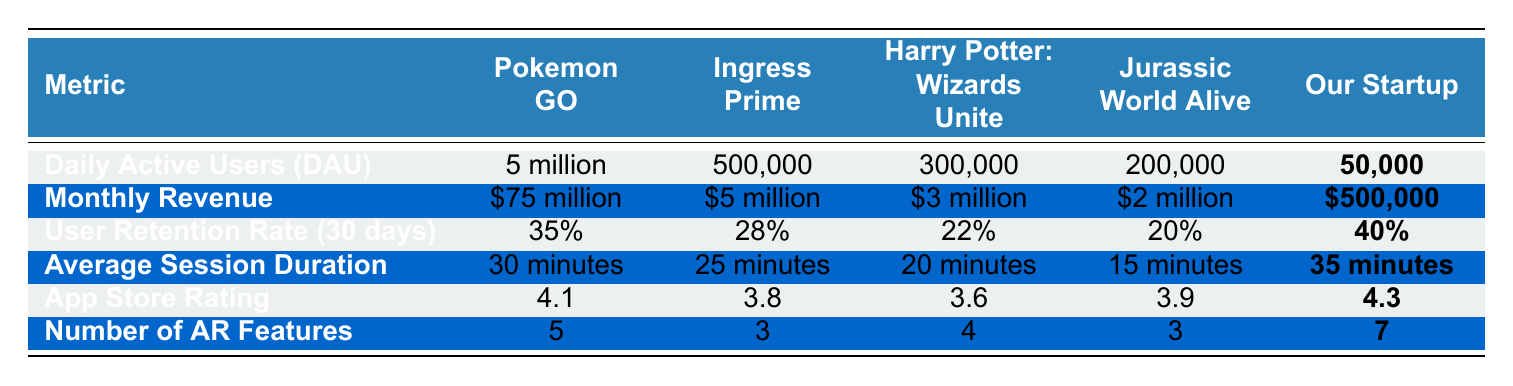What are the Daily Active Users (DAU) of Pokemon GO? The DAU for Pokemon GO is directly listed in the table under the corresponding metric. It is stated as "5 million."
Answer: 5 million Which app has the highest Monthly Revenue? The Monthly Revenue for each app is listed in a separate row. Comparing these values shows that Pokemon GO has the highest with "$75 million."
Answer: $75 million Is our startup's User Retention Rate higher than Ingress Prime's? The User Retention Rate for our startup is given as "40%" and for Ingress Prime as "28%." Since 40% is greater than 28%, the answer is yes.
Answer: Yes What is the average number of AR Features across all five apps? To find the average, sum up the number of AR Features for each app: 5 (Pokemon GO) + 3 (Ingress Prime) + 4 (Harry Potter) + 3 (Jurassic World) + 7 (Our Startup) = 22. Divide by the total number of apps (5) to get an average of 22/5 = 4.4.
Answer: 4.4 Does Harry Potter: Wizards Unite have a higher App Store Rating than Jurassic World Alive? The App Store Ratings are 3.6 for Harry Potter: Wizards Unite and 3.9 for Jurassic World Alive. Since 3.6 is less than 3.9, the answer is no.
Answer: No What is the difference in Average Session Duration between Pokemon GO and Our Startup? The Average Session Duration for Pokemon GO is 30 minutes, and for Our Startup, it is 35 minutes. To find the difference, subtract 30 from 35, which equals 5 minutes.
Answer: 5 minutes Which app has the lowest DAU among the listed games? By examining the DAU for each app listed, "Our Startup" shows the lowest value at 50,000 compared to others.
Answer: Our Startup If we combine the Monthly Revenues of the three lowest-grossing apps (Harry Potter, Jurassic World, Our Startup), what would the total be? The Monthly Revenues for these apps are $3 million (Harry Potter) + $2 million (Jurassic World) + $500,000 (Our Startup). This results in a total of $5.5 million.
Answer: $5.5 million Which app has the best App Store Rating? By checking the values in the App Store Rating row, we find that "Our Startup" has the highest rating at 4.3.
Answer: 4.3 